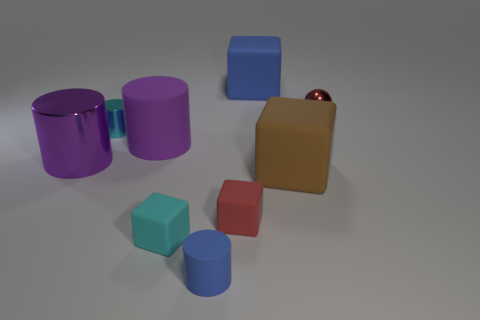Subtract all brown matte blocks. How many blocks are left? 3 Add 1 red matte objects. How many objects exist? 10 Subtract all cyan blocks. How many blocks are left? 3 Subtract all gray blocks. How many purple cylinders are left? 2 Subtract all cylinders. How many objects are left? 5 Add 2 small cyan metallic things. How many small cyan metallic things are left? 3 Add 3 blue cubes. How many blue cubes exist? 4 Subtract 0 gray blocks. How many objects are left? 9 Subtract 1 blocks. How many blocks are left? 3 Subtract all gray cylinders. Subtract all gray blocks. How many cylinders are left? 4 